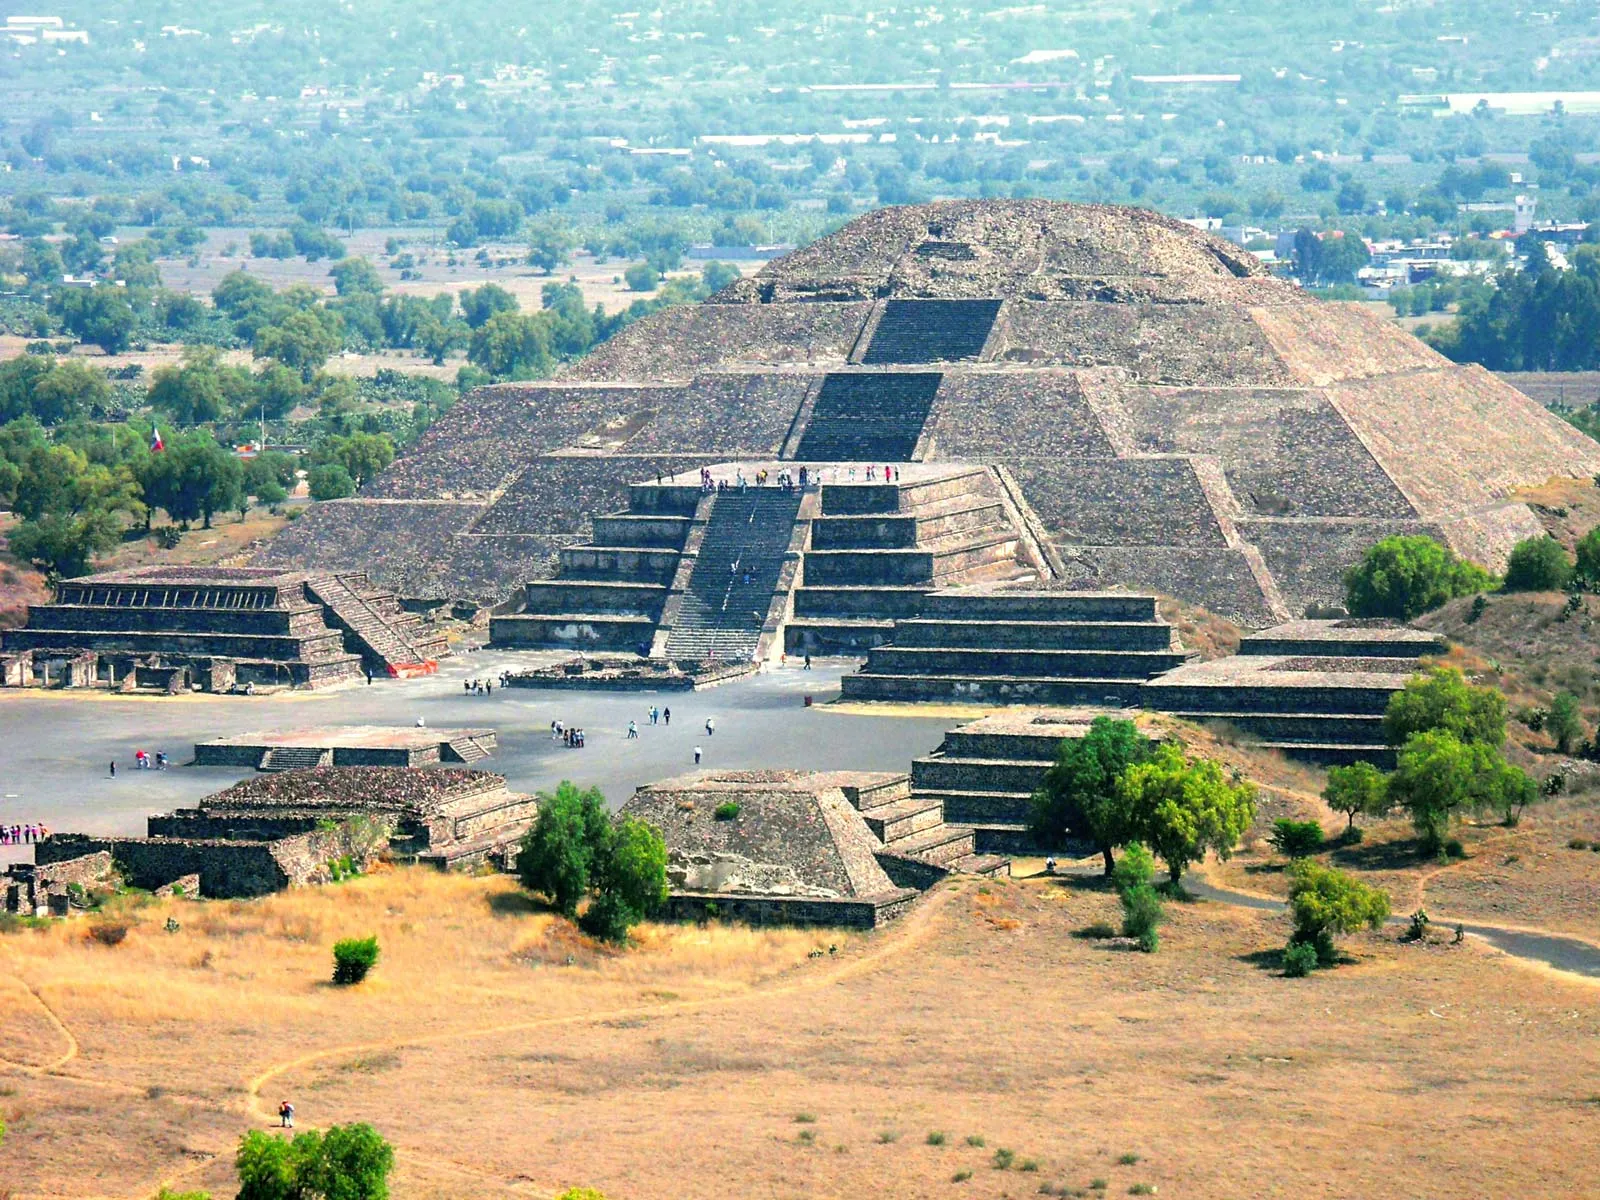If this pyramid could talk, what stories might it tell? If the Pyramid of the Sun could speak, it might tell stories of the grand ceremonies and rituals that were once held upon its steps, where priests conducted offerings to deities in hopes of bountiful harvests and protection from calamities. It could recount the countless generations of people who contributed to its construction, each stone a testament to their hard work and devotion. The pyramid might share tales of the rise and fall of the Teotihuacan civilization, the bustling markets, the artistic achievements, and the vibrant cultural exchanges that happened in its shadow. It would also likely speak of the mysteries that remain unsolved, the ancient knowledge encoded in its precise alignment with stars, and the enduring legacy it represents as a monument to human ingenuity and spiritual connection. 